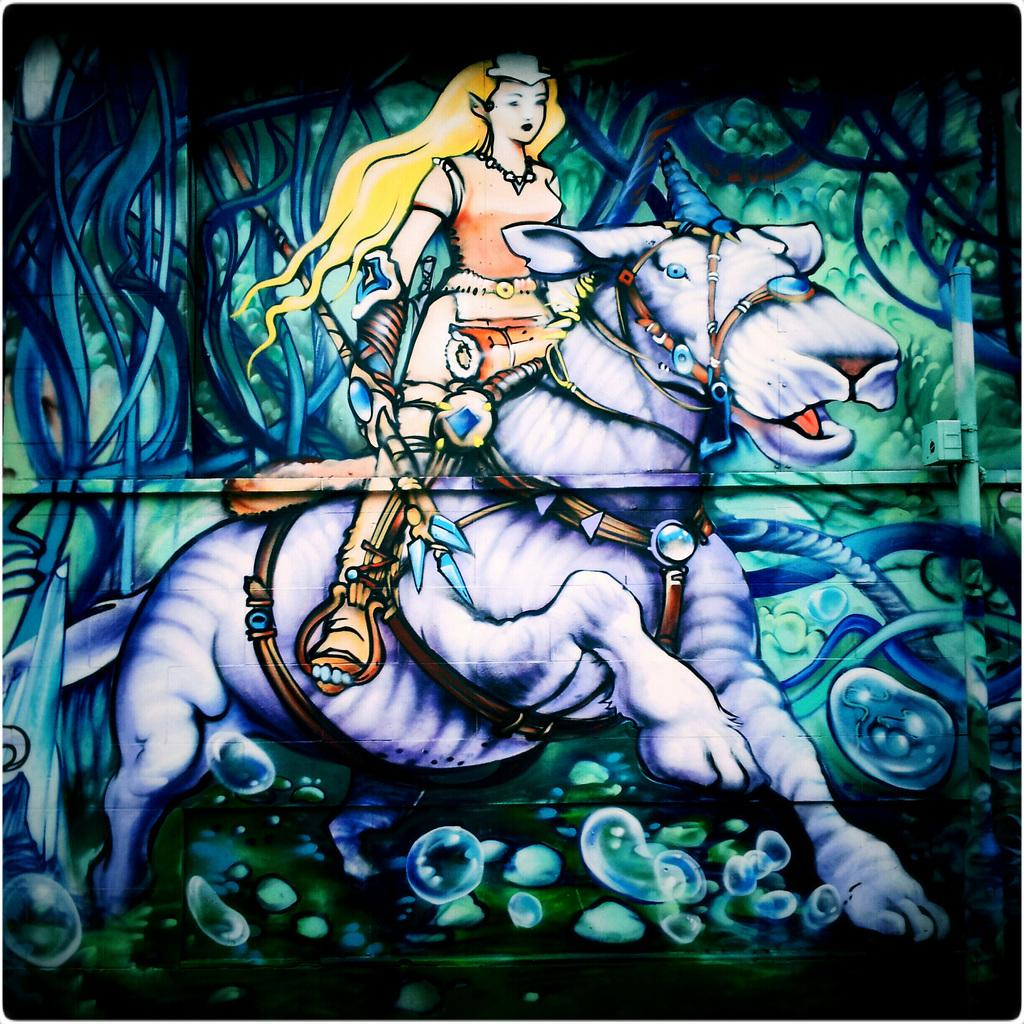Who is the main subject in the painting? There is a woman in the painting. What is the woman holding in the painting? The woman is holding a stick. What is the woman sitting on in the painting? The woman is sitting on an animal that is running. What can be seen in the background of the painting? There are other objects in the background of the painting. What type of appliance can be seen in the painting? There is no appliance present in the painting; it features a woman holding a stick while sitting on a running animal. 